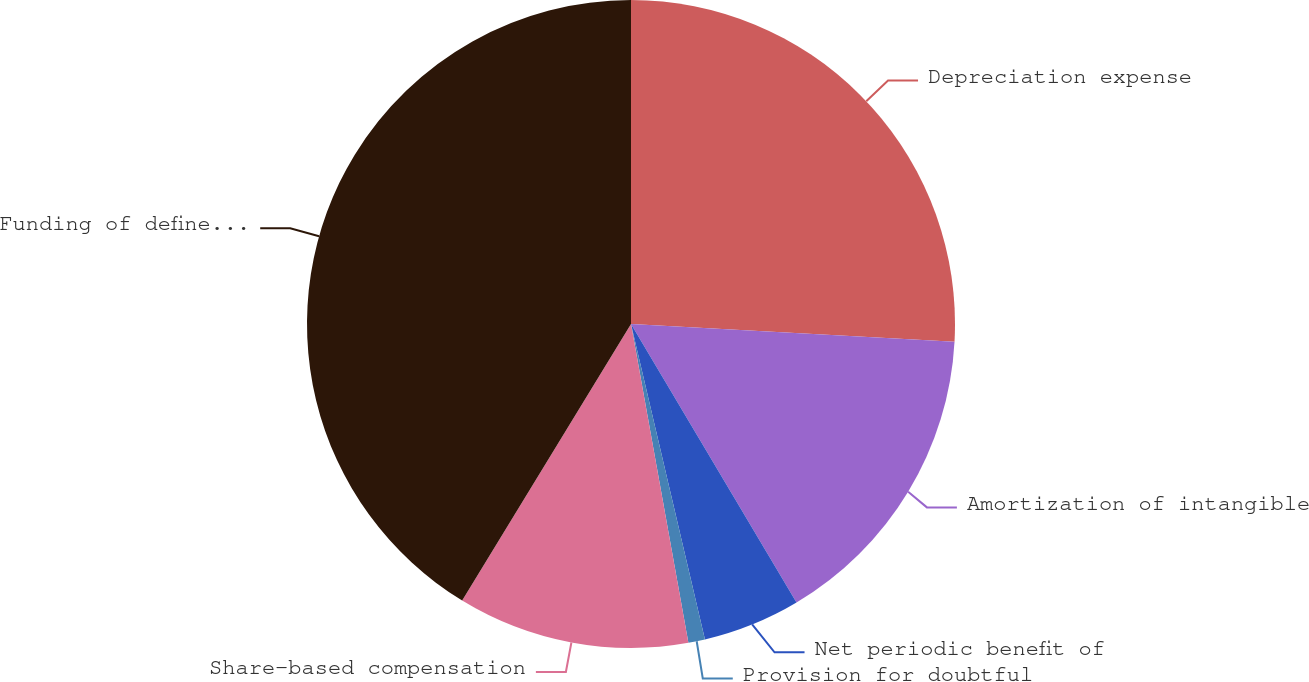Convert chart to OTSL. <chart><loc_0><loc_0><loc_500><loc_500><pie_chart><fcel>Depreciation expense<fcel>Amortization of intangible<fcel>Net periodic benefit of<fcel>Provision for doubtful<fcel>Share-based compensation<fcel>Funding of defined benefit<nl><fcel>25.87%<fcel>15.6%<fcel>4.87%<fcel>0.83%<fcel>11.56%<fcel>41.28%<nl></chart> 